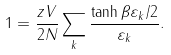<formula> <loc_0><loc_0><loc_500><loc_500>1 = \frac { z V } { 2 N } \sum _ { k } \frac { \tanh \beta \varepsilon _ { k } / 2 } { \varepsilon _ { k } } .</formula> 